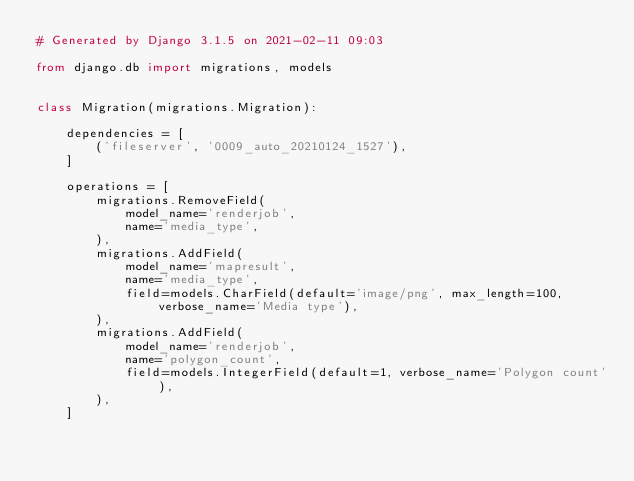<code> <loc_0><loc_0><loc_500><loc_500><_Python_># Generated by Django 3.1.5 on 2021-02-11 09:03

from django.db import migrations, models


class Migration(migrations.Migration):

    dependencies = [
        ('fileserver', '0009_auto_20210124_1527'),
    ]

    operations = [
        migrations.RemoveField(
            model_name='renderjob',
            name='media_type',
        ),
        migrations.AddField(
            model_name='mapresult',
            name='media_type',
            field=models.CharField(default='image/png', max_length=100, verbose_name='Media type'),
        ),
        migrations.AddField(
            model_name='renderjob',
            name='polygon_count',
            field=models.IntegerField(default=1, verbose_name='Polygon count'),
        ),
    ]
</code> 